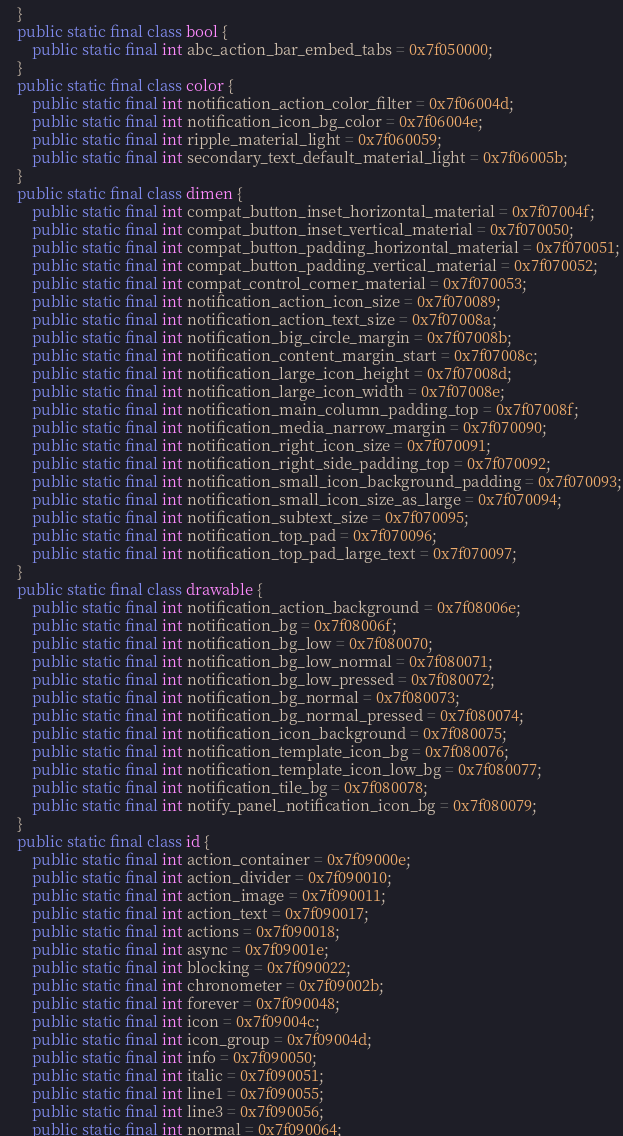Convert code to text. <code><loc_0><loc_0><loc_500><loc_500><_Java_>    }
    public static final class bool {
        public static final int abc_action_bar_embed_tabs = 0x7f050000;
    }
    public static final class color {
        public static final int notification_action_color_filter = 0x7f06004d;
        public static final int notification_icon_bg_color = 0x7f06004e;
        public static final int ripple_material_light = 0x7f060059;
        public static final int secondary_text_default_material_light = 0x7f06005b;
    }
    public static final class dimen {
        public static final int compat_button_inset_horizontal_material = 0x7f07004f;
        public static final int compat_button_inset_vertical_material = 0x7f070050;
        public static final int compat_button_padding_horizontal_material = 0x7f070051;
        public static final int compat_button_padding_vertical_material = 0x7f070052;
        public static final int compat_control_corner_material = 0x7f070053;
        public static final int notification_action_icon_size = 0x7f070089;
        public static final int notification_action_text_size = 0x7f07008a;
        public static final int notification_big_circle_margin = 0x7f07008b;
        public static final int notification_content_margin_start = 0x7f07008c;
        public static final int notification_large_icon_height = 0x7f07008d;
        public static final int notification_large_icon_width = 0x7f07008e;
        public static final int notification_main_column_padding_top = 0x7f07008f;
        public static final int notification_media_narrow_margin = 0x7f070090;
        public static final int notification_right_icon_size = 0x7f070091;
        public static final int notification_right_side_padding_top = 0x7f070092;
        public static final int notification_small_icon_background_padding = 0x7f070093;
        public static final int notification_small_icon_size_as_large = 0x7f070094;
        public static final int notification_subtext_size = 0x7f070095;
        public static final int notification_top_pad = 0x7f070096;
        public static final int notification_top_pad_large_text = 0x7f070097;
    }
    public static final class drawable {
        public static final int notification_action_background = 0x7f08006e;
        public static final int notification_bg = 0x7f08006f;
        public static final int notification_bg_low = 0x7f080070;
        public static final int notification_bg_low_normal = 0x7f080071;
        public static final int notification_bg_low_pressed = 0x7f080072;
        public static final int notification_bg_normal = 0x7f080073;
        public static final int notification_bg_normal_pressed = 0x7f080074;
        public static final int notification_icon_background = 0x7f080075;
        public static final int notification_template_icon_bg = 0x7f080076;
        public static final int notification_template_icon_low_bg = 0x7f080077;
        public static final int notification_tile_bg = 0x7f080078;
        public static final int notify_panel_notification_icon_bg = 0x7f080079;
    }
    public static final class id {
        public static final int action_container = 0x7f09000e;
        public static final int action_divider = 0x7f090010;
        public static final int action_image = 0x7f090011;
        public static final int action_text = 0x7f090017;
        public static final int actions = 0x7f090018;
        public static final int async = 0x7f09001e;
        public static final int blocking = 0x7f090022;
        public static final int chronometer = 0x7f09002b;
        public static final int forever = 0x7f090048;
        public static final int icon = 0x7f09004c;
        public static final int icon_group = 0x7f09004d;
        public static final int info = 0x7f090050;
        public static final int italic = 0x7f090051;
        public static final int line1 = 0x7f090055;
        public static final int line3 = 0x7f090056;
        public static final int normal = 0x7f090064;</code> 